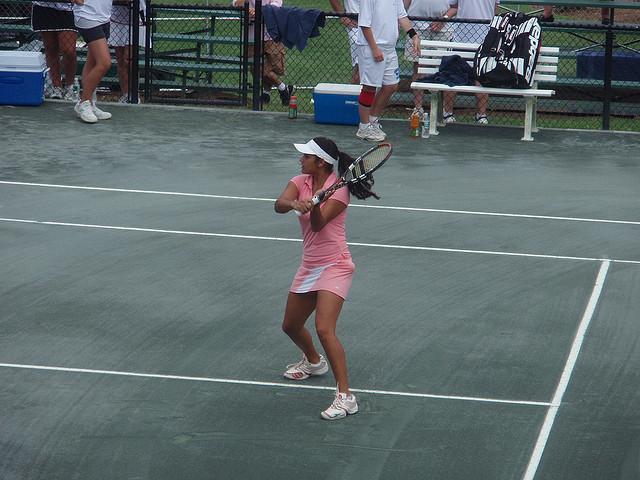What object can keep beverages cold?
From the following four choices, select the correct answer to address the question.
Options: Cooler, bench, racquet, shoes. Cooler. 